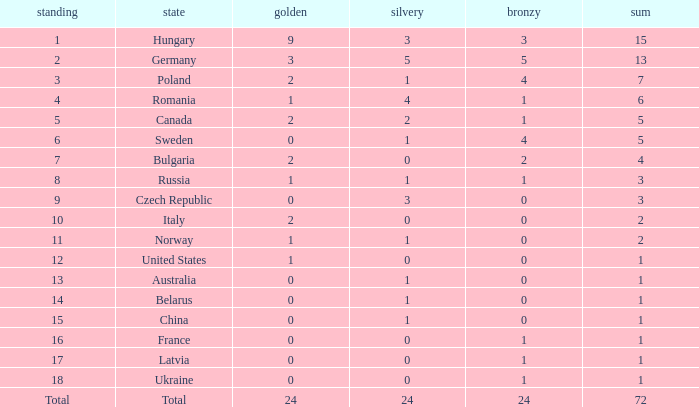What average silver has belarus as the nation, with a total less than 1? None. 